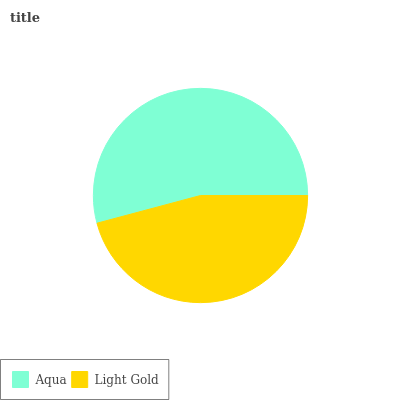Is Light Gold the minimum?
Answer yes or no. Yes. Is Aqua the maximum?
Answer yes or no. Yes. Is Light Gold the maximum?
Answer yes or no. No. Is Aqua greater than Light Gold?
Answer yes or no. Yes. Is Light Gold less than Aqua?
Answer yes or no. Yes. Is Light Gold greater than Aqua?
Answer yes or no. No. Is Aqua less than Light Gold?
Answer yes or no. No. Is Aqua the high median?
Answer yes or no. Yes. Is Light Gold the low median?
Answer yes or no. Yes. Is Light Gold the high median?
Answer yes or no. No. Is Aqua the low median?
Answer yes or no. No. 